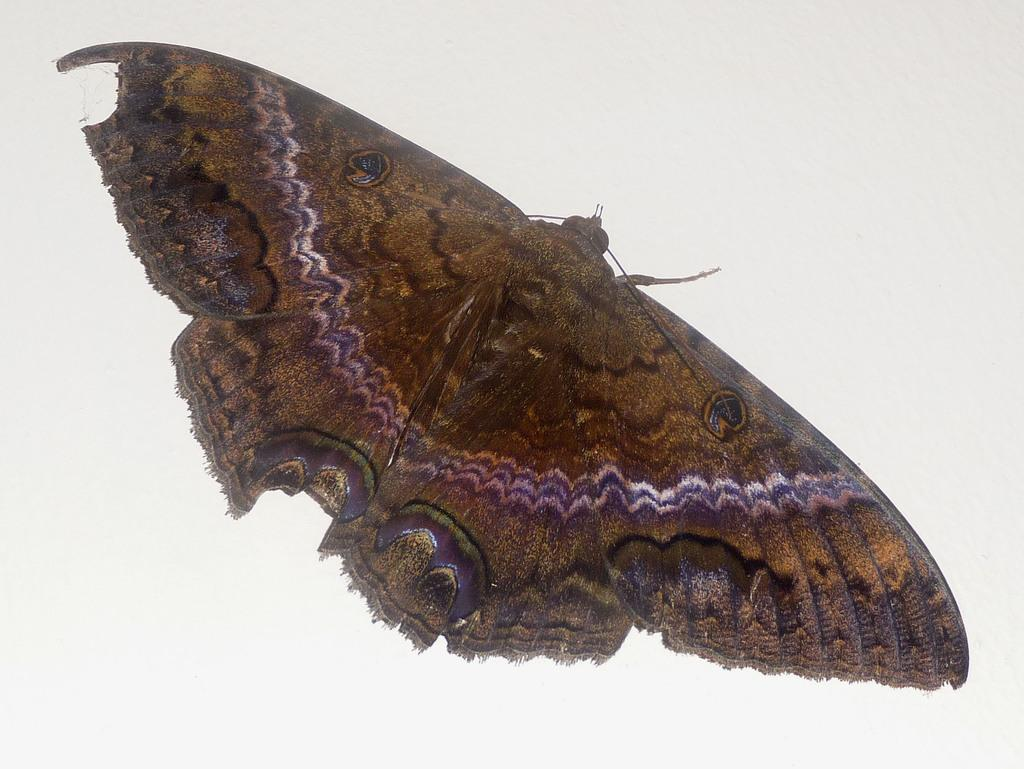What is the main subject of the picture? The main subject of the picture is a butterfly. Can you describe the color of the butterfly? The butterfly is brown in color. What is the background of the picture? The background of the picture is white. How does the butterfly represent the expansion of the company in the image? The image does not depict any company or expansion, and the butterfly is not used as a symbol for such. 